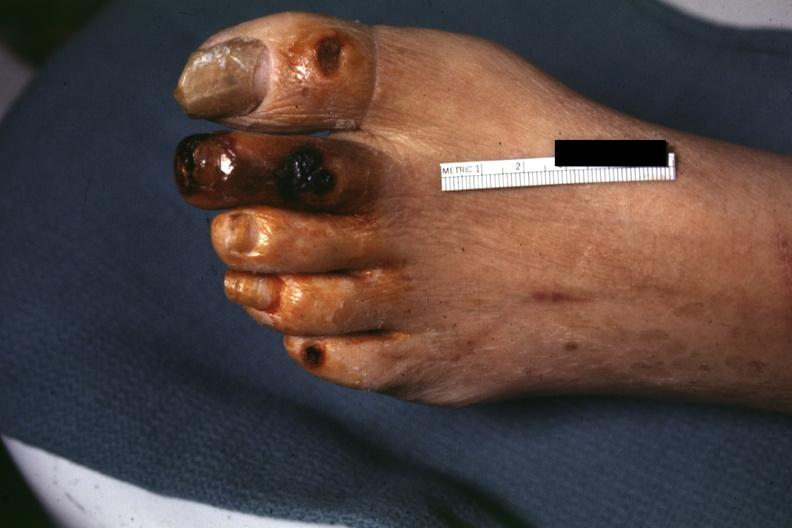s immunostain for growth hormone present?
Answer the question using a single word or phrase. No 